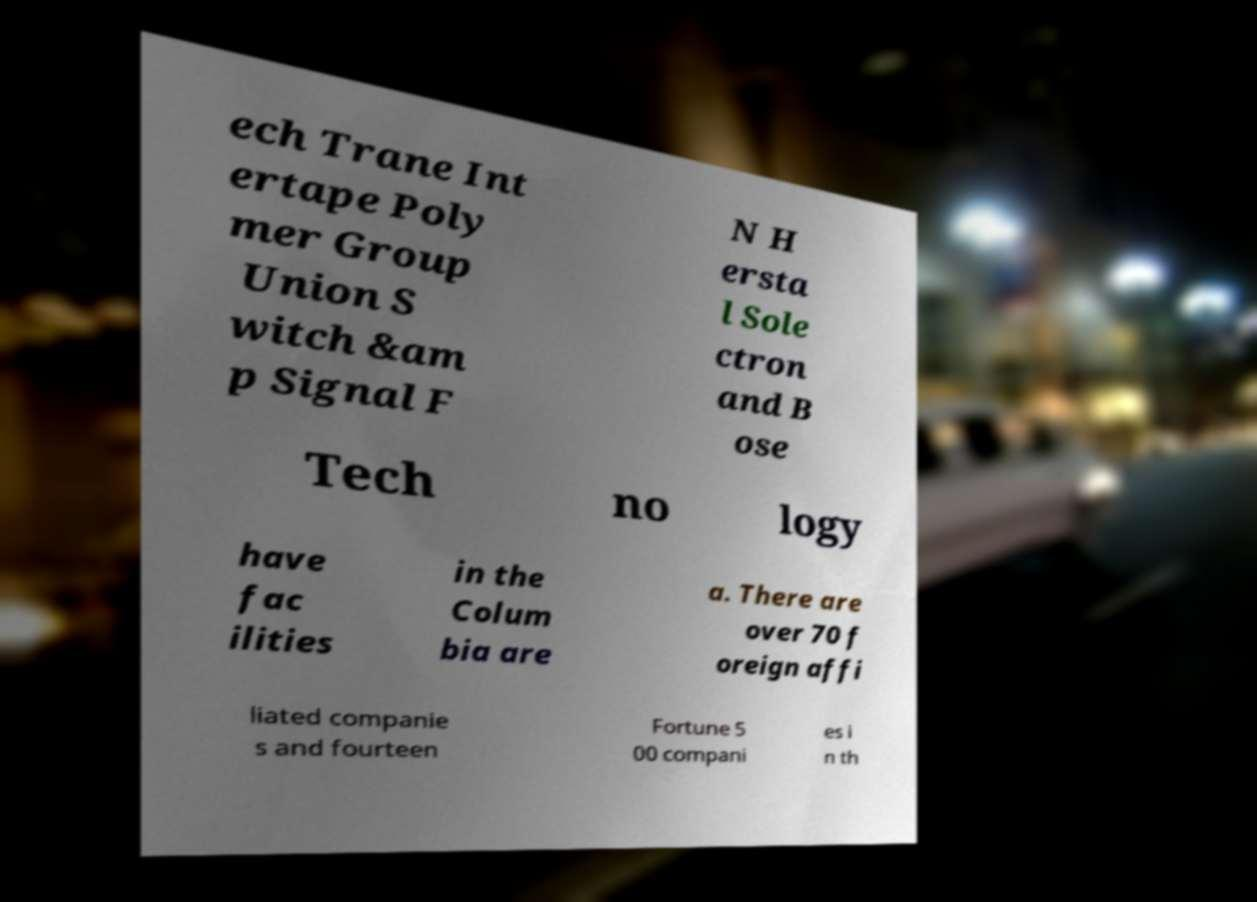Please read and relay the text visible in this image. What does it say? ech Trane Int ertape Poly mer Group Union S witch &am p Signal F N H ersta l Sole ctron and B ose Tech no logy have fac ilities in the Colum bia are a. There are over 70 f oreign affi liated companie s and fourteen Fortune 5 00 compani es i n th 